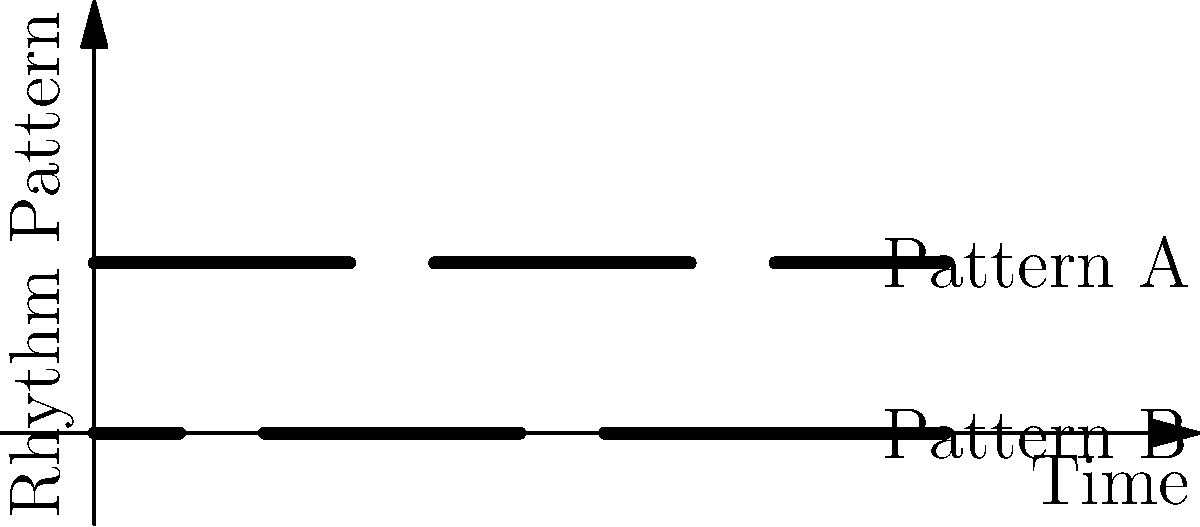Consider the two Akan drum rhythm patterns shown in the diagram. If we define a group operation where combining two rhythms results in playing them simultaneously, which of the following statements is true about the group structure formed by these rhythms?

a) The group is cyclic
b) The group is non-abelian
c) The group has order 4
d) The group is isomorphic to $\mathbb{Z}_2 \times \mathbb{Z}_2$ Let's analyze this step-by-step:

1) First, we need to identify the elements of the group. We have:
   - Pattern A (let's call it a)
   - Pattern B (let's call it b)
   - The combination of A and B played simultaneously (let's call it ab)
   - The identity element, which would be silence or no rhythm (let's call it e)

2) The group operation is playing rhythms simultaneously. This operation is:
   - Associative: (a * b) * c = a * (b * c) for any rhythms a, b, c
   - Has an identity element: e * a = a * e = a for any rhythm a
   - Has inverse elements: For each rhythm, playing it with silence gives silence

3) Now, let's check the properties:
   - Is it cyclic? No, because neither a nor b generates the whole group.
   - Is it non-abelian? No, a * b = b * a (playing A and B simultaneously is the same regardless of order).
   - Does it have order 4? Yes, it has 4 elements: e, a, b, and ab.
   - Is it isomorphic to $\mathbb{Z}_2 \times \mathbb{Z}_2$? Yes, because:
     * It's abelian
     * It has order 4
     * Every non-identity element has order 2 (a * a = b * b = ab * ab = e)

4) Therefore, the correct answer is d). The group is isomorphic to $\mathbb{Z}_2 \times \mathbb{Z}_2$.
Answer: d) The group is isomorphic to $\mathbb{Z}_2 \times \mathbb{Z}_2$ 